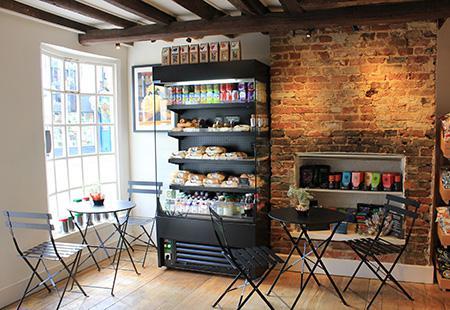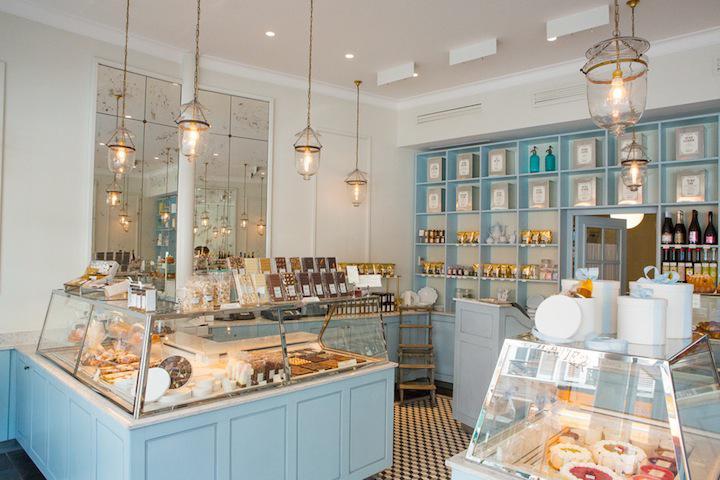The first image is the image on the left, the second image is the image on the right. Analyze the images presented: Is the assertion "The interior of a shop has a row of suspended white lights over a pale painted counter with glass display case on top." valid? Answer yes or no. Yes. 